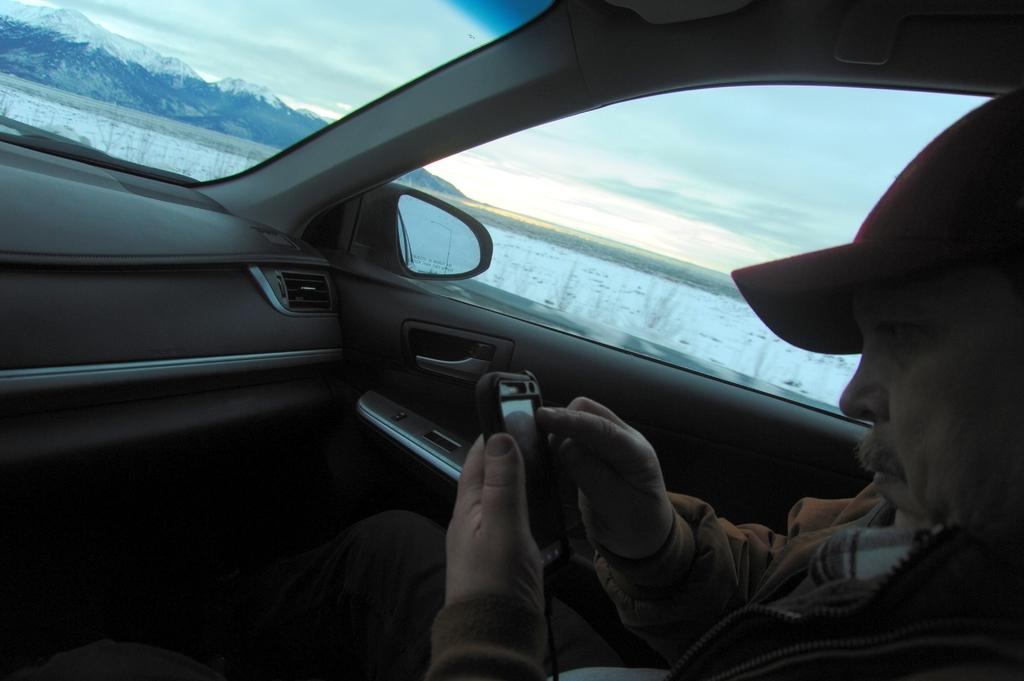What is the person in the car doing? The person is catching a phone. What can be seen outside the car? There is a clear sky, mountains, and water visible outside the car. What is the weather like outside the car? The clear sky suggests good weather outside the car. What type of landscape is visible outside the car? The mountains and water suggest a scenic landscape outside the car. What type of pest can be seen crawling on the roof of the car in the image? There is no roof visible in the image, as it is focused on the person in the car and the surrounding environment. Additionally, there is no mention of any pests in the provided facts. 